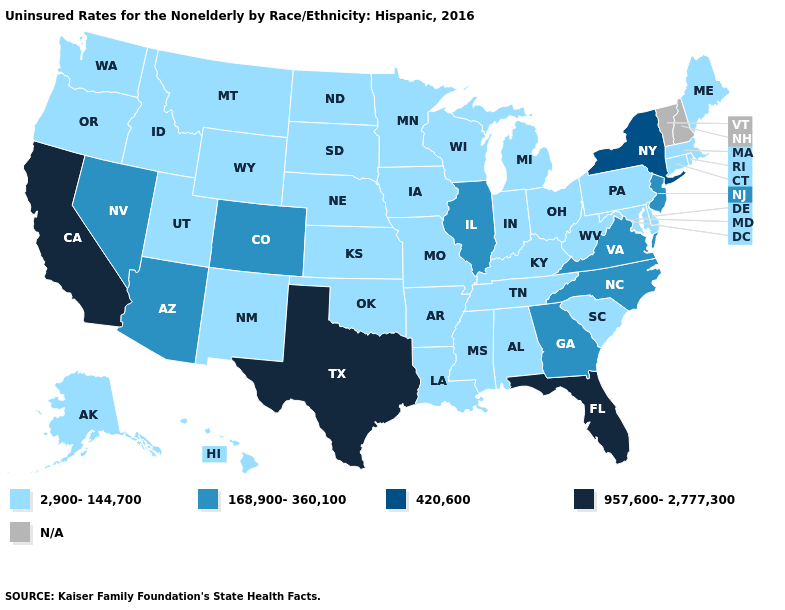What is the value of Tennessee?
Answer briefly. 2,900-144,700. What is the highest value in states that border Georgia?
Give a very brief answer. 957,600-2,777,300. What is the highest value in the USA?
Short answer required. 957,600-2,777,300. Which states have the lowest value in the USA?
Answer briefly. Alabama, Alaska, Arkansas, Connecticut, Delaware, Hawaii, Idaho, Indiana, Iowa, Kansas, Kentucky, Louisiana, Maine, Maryland, Massachusetts, Michigan, Minnesota, Mississippi, Missouri, Montana, Nebraska, New Mexico, North Dakota, Ohio, Oklahoma, Oregon, Pennsylvania, Rhode Island, South Carolina, South Dakota, Tennessee, Utah, Washington, West Virginia, Wisconsin, Wyoming. Is the legend a continuous bar?
Be succinct. No. What is the value of Kentucky?
Concise answer only. 2,900-144,700. What is the highest value in states that border Florida?
Quick response, please. 168,900-360,100. Does the first symbol in the legend represent the smallest category?
Answer briefly. Yes. Does the map have missing data?
Give a very brief answer. Yes. Does Florida have the highest value in the USA?
Keep it brief. Yes. Does South Dakota have the lowest value in the MidWest?
Be succinct. Yes. What is the highest value in the West ?
Quick response, please. 957,600-2,777,300. Does Utah have the lowest value in the West?
Concise answer only. Yes. Which states hav the highest value in the West?
Concise answer only. California. 